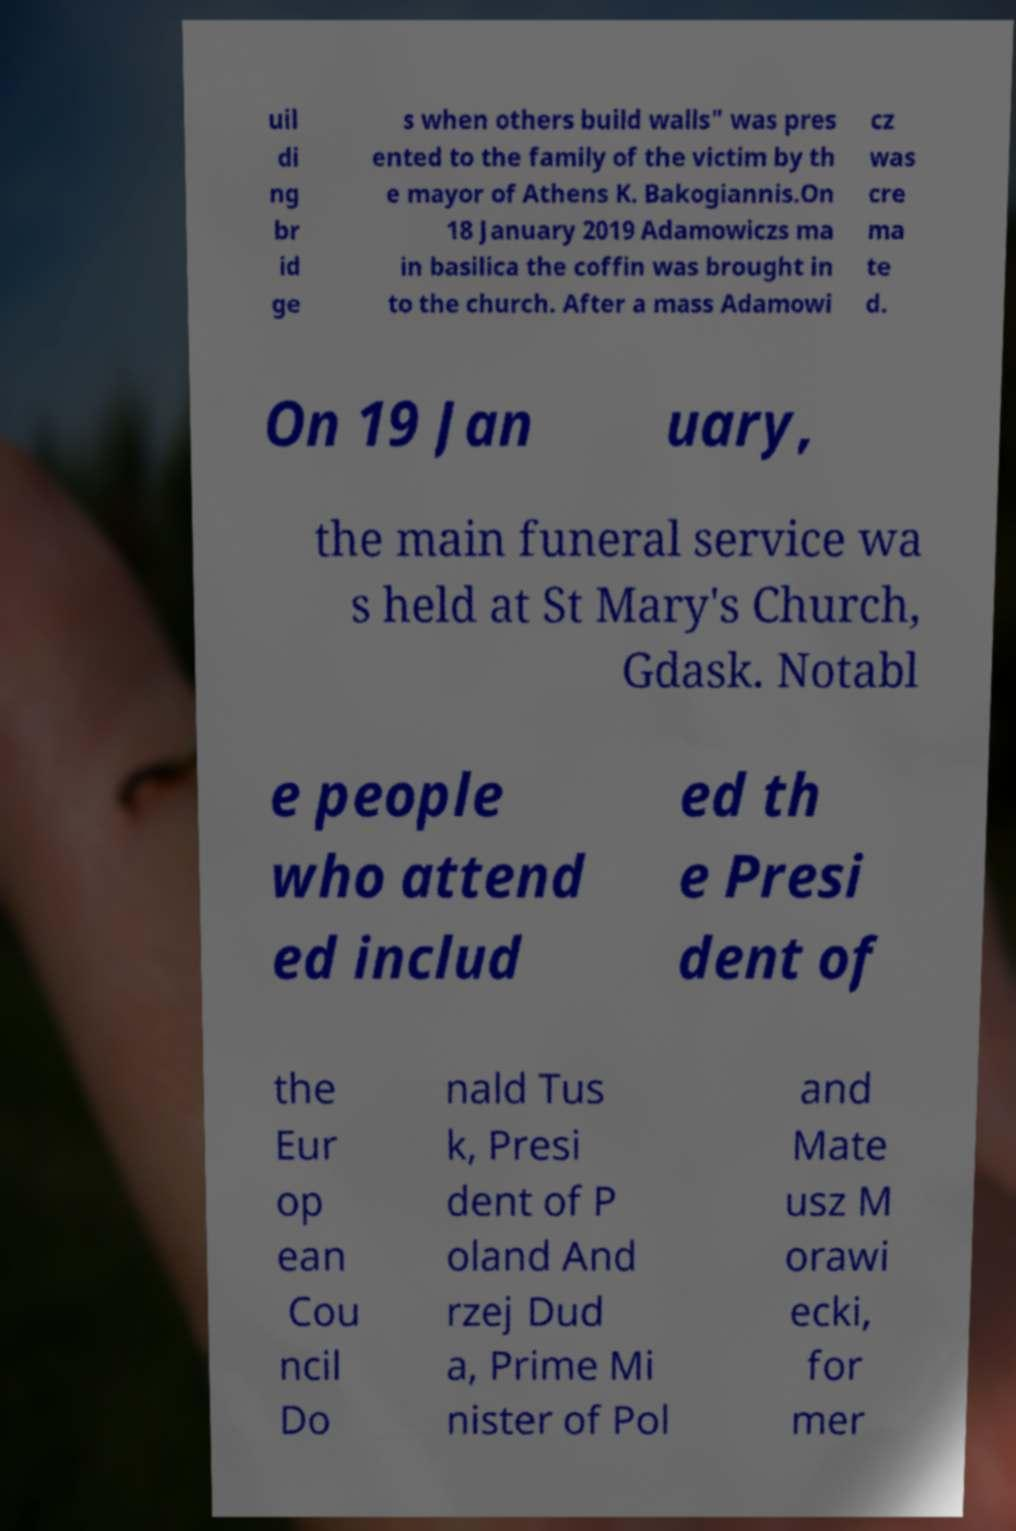Could you assist in decoding the text presented in this image and type it out clearly? uil di ng br id ge s when others build walls" was pres ented to the family of the victim by th e mayor of Athens K. Bakogiannis.On 18 January 2019 Adamowiczs ma in basilica the coffin was brought in to the church. After a mass Adamowi cz was cre ma te d. On 19 Jan uary, the main funeral service wa s held at St Mary's Church, Gdask. Notabl e people who attend ed includ ed th e Presi dent of the Eur op ean Cou ncil Do nald Tus k, Presi dent of P oland And rzej Dud a, Prime Mi nister of Pol and Mate usz M orawi ecki, for mer 